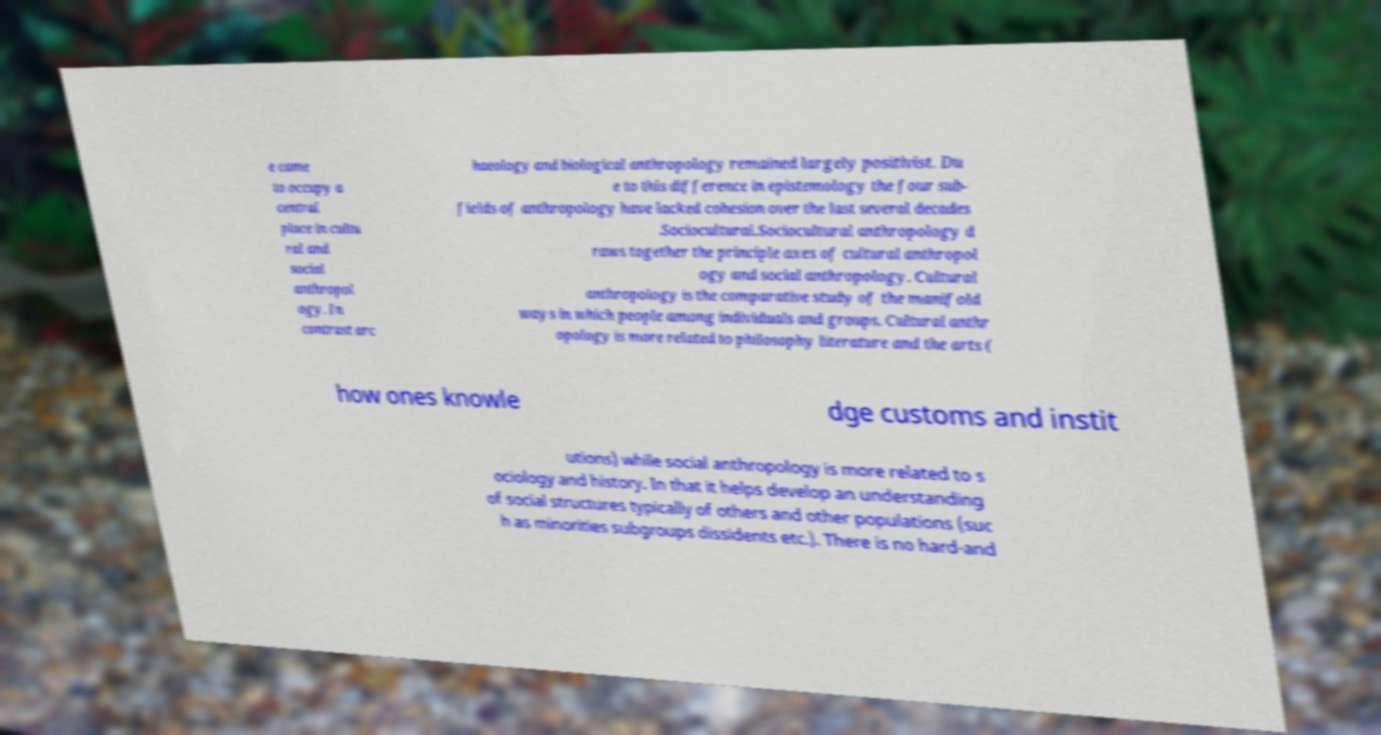Could you assist in decoding the text presented in this image and type it out clearly? e came to occupy a central place in cultu ral and social anthropol ogy. In contrast arc haeology and biological anthropology remained largely positivist. Du e to this difference in epistemology the four sub- fields of anthropology have lacked cohesion over the last several decades .Sociocultural.Sociocultural anthropology d raws together the principle axes of cultural anthropol ogy and social anthropology. Cultural anthropology is the comparative study of the manifold ways in which people among individuals and groups. Cultural anthr opology is more related to philosophy literature and the arts ( how ones knowle dge customs and instit utions) while social anthropology is more related to s ociology and history. In that it helps develop an understanding of social structures typically of others and other populations (suc h as minorities subgroups dissidents etc.). There is no hard-and 